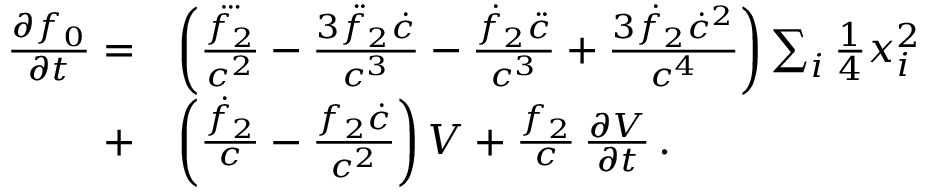Convert formula to latex. <formula><loc_0><loc_0><loc_500><loc_500>\begin{array} { r l } { \frac { \partial f _ { 0 } } { \partial t } = } & { \left ( \frac { \dddot { f _ { 2 } } } { c ^ { 2 } } - \frac { 3 \ddot { f } _ { 2 } \dot { c } } { c ^ { 3 } } - \frac { \dot { f } _ { 2 } \ddot { c } } { c ^ { 3 } } + \frac { 3 \dot { f } _ { 2 } \dot { c } ^ { 2 } } { c ^ { 4 } } \right ) \sum _ { i } { \frac { 1 } { 4 } } x _ { i } ^ { 2 } } \\ { + } & { \left ( \frac { \dot { f } _ { 2 } } { c } - \frac { f _ { 2 } \dot { c } } { c ^ { 2 } } \right ) V + \frac { f _ { 2 } } { c } \, \frac { \partial V } { \partial t } \, . } \end{array}</formula> 